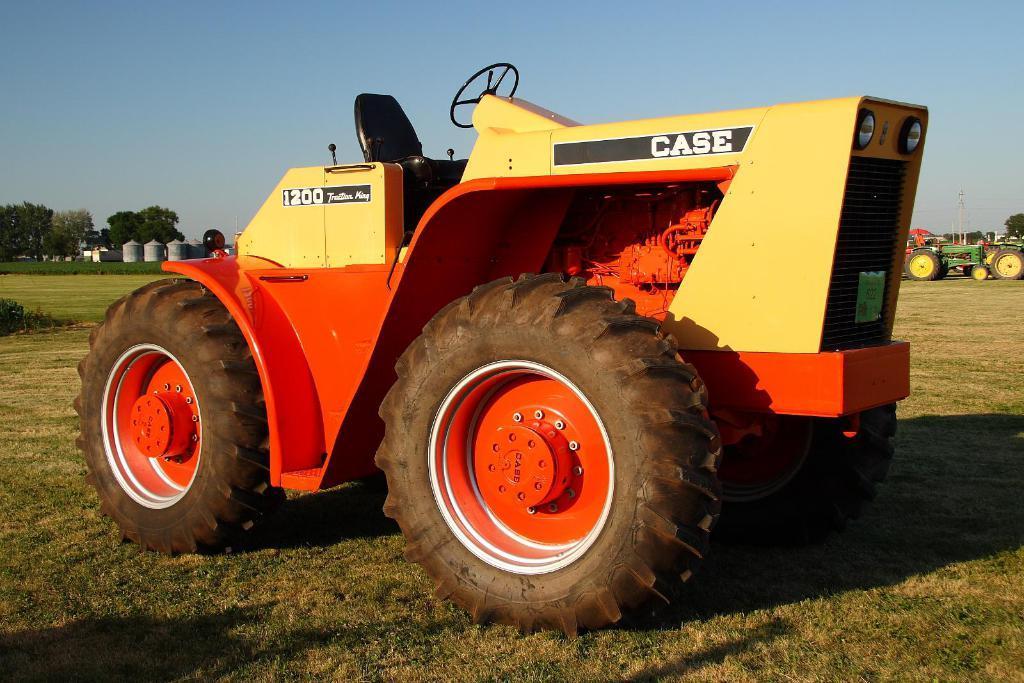Could you give a brief overview of what you see in this image? In this image in the center there is vehicle with some text written on it and there are numbers written on the vehicle. In the background there are trees, vehicles and there are objects which are white in colour. 